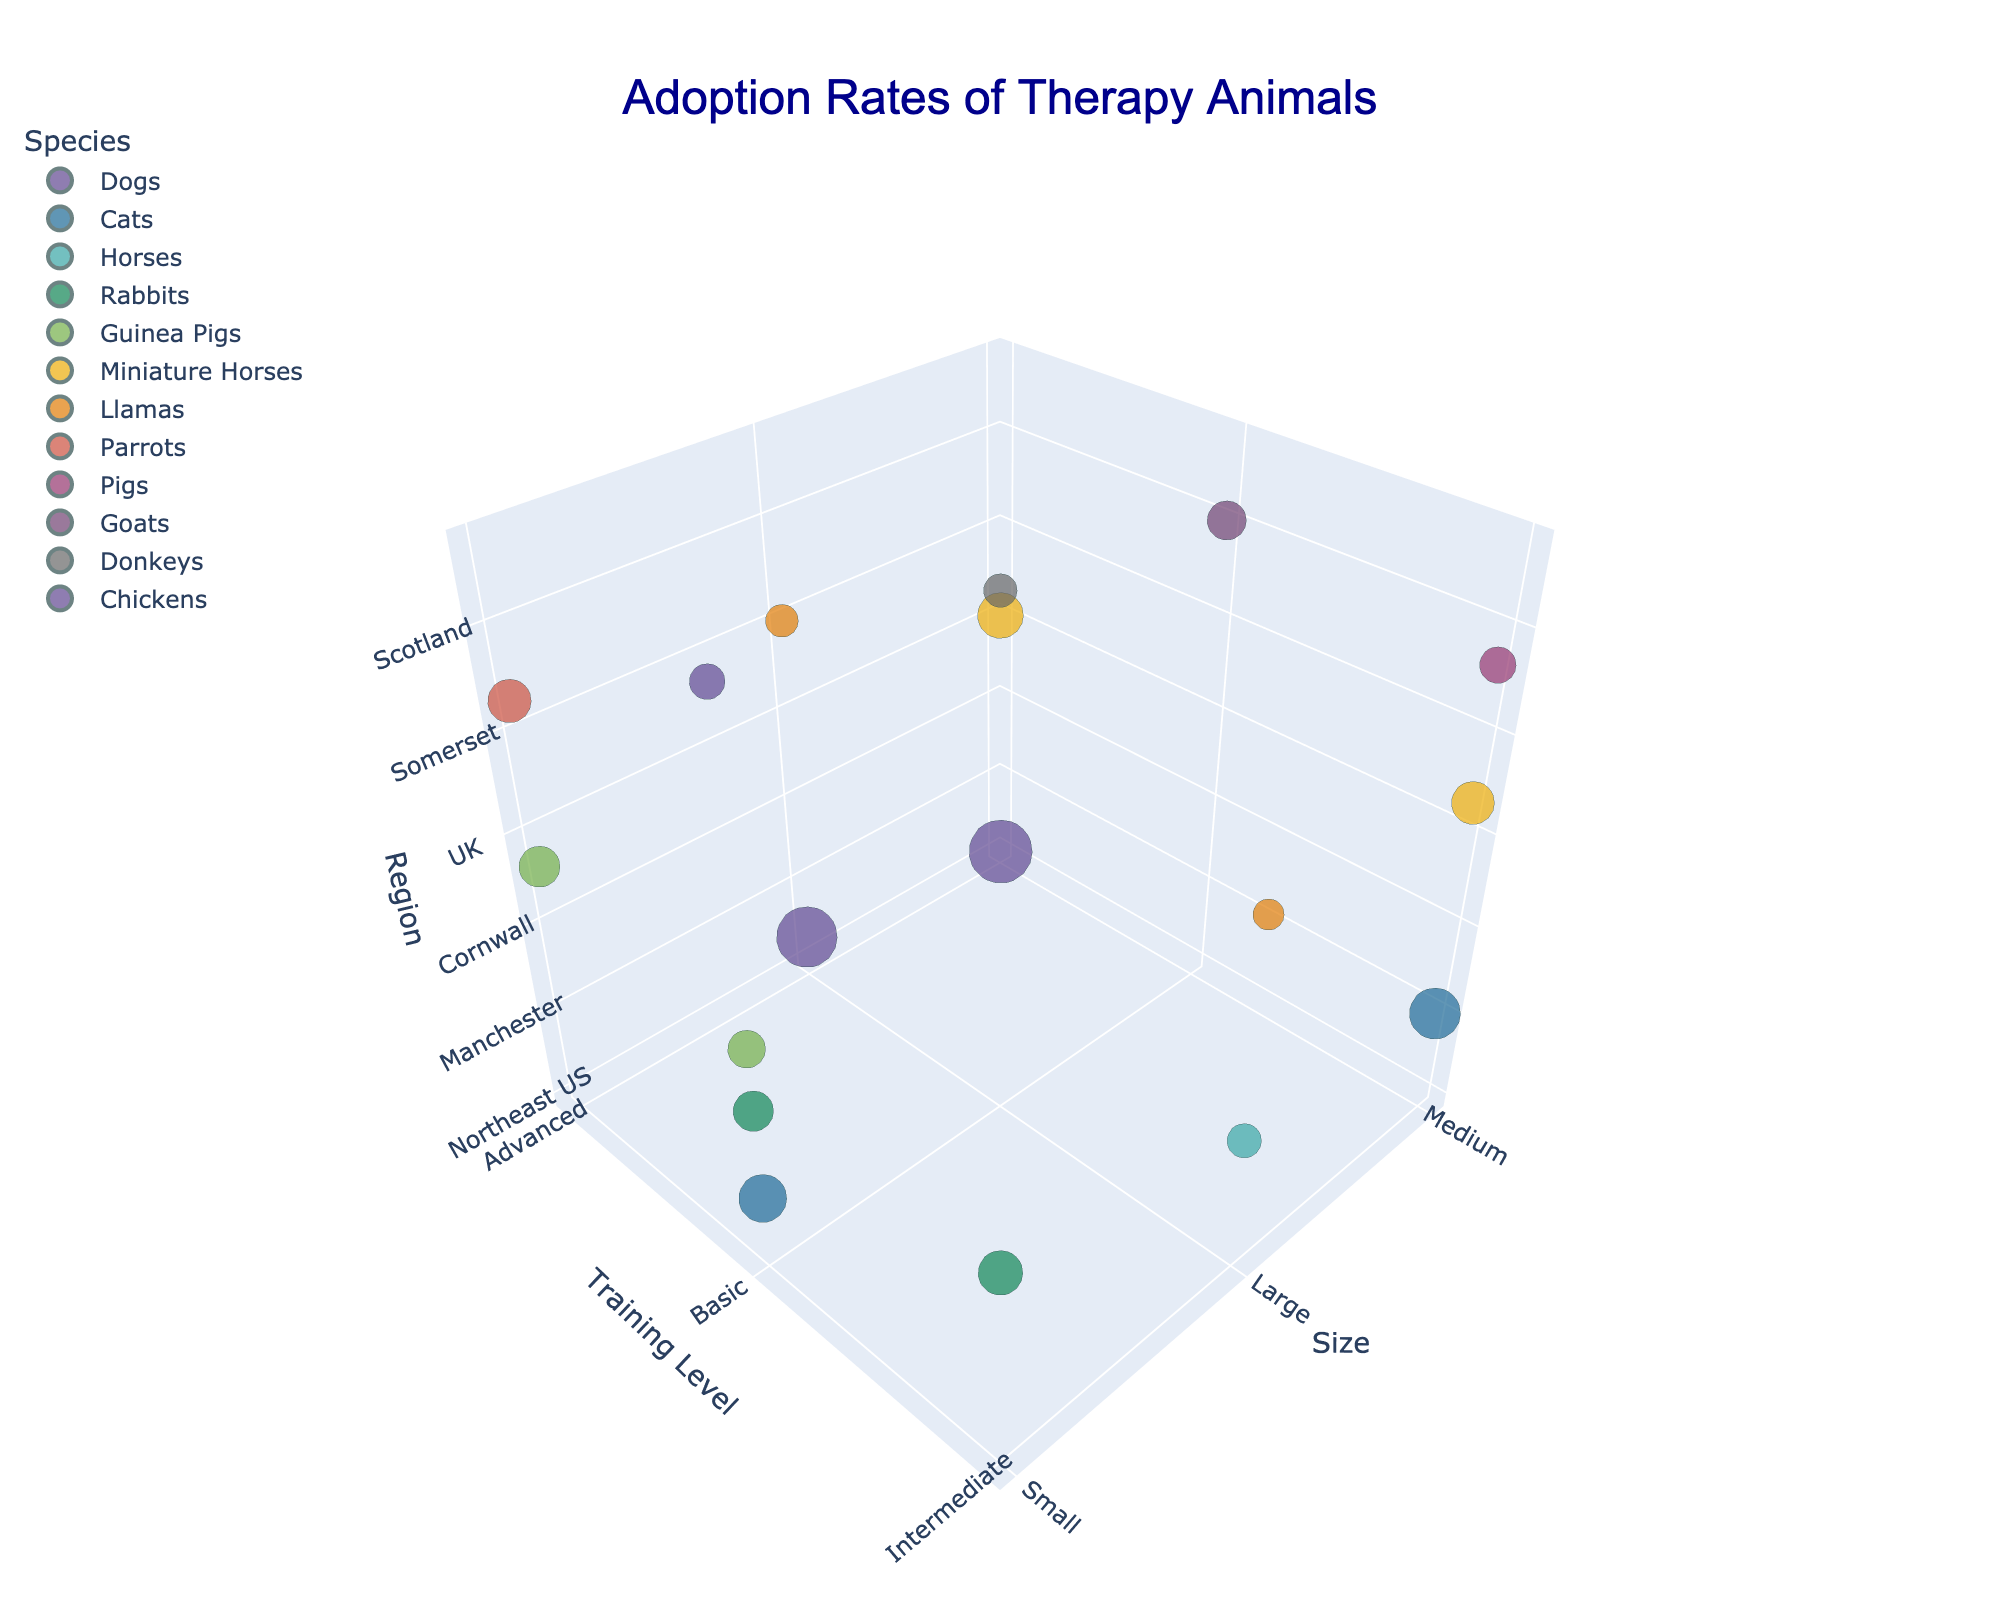How many species of therapy animals are shown in the figure? To find the number of species, count the unique labels under the 'Species' category.
Answer: 11 What is the adoption rate of medium-sized dogs with advanced training in Northeast US? Locate the bubble representing medium-sized dogs with advanced training and check the adoption rate value.
Answer: 78 Which species has the highest adoption rate, and what is it? Identify the largest bubble across all the regions, sizes, and training levels. Find out its corresponding species and adoption rate.
Answer: Dogs, 78 Compare the adoption rates of therapy animals in Australia and Ireland. Which region has a lower adoption rate, and by how much? Find the bubbles representing Australia and Ireland, then subtract the lower adoption rate from the higher one. Llamas in Australia have an adoption rate of 19, and donkeys in Ireland have 22.
Answer: Australia, by 3 What is the adoption rate for small, basic cats in Southeast US compared to medium, advanced dogs in London? Identify the respective bubbles and compare their adoption rates directly from the figure. Cats have an adoption rate of 45, and dogs have 72.
Answer: Dogs, 72; Cats, 45 Which region has more variety in the sizes of therapy animals: Southwest US or UK? Count the different sizes (small, medium, large) of therapy animals present in each region. The Southwest US has small animals (Guinea Pigs), and the UK has medium and large animals (Miniature Horses, Llamas).
Answer: UK Which animal with intermediate training has the highest adoption rate? Look for the bubble indicating the highest adoption rate among those labeled with intermediate training levels. Cats in Manchester have an adoption rate of 51.
Answer: Cats in Manchester How does the adoption rate of rabbits with basic training in West Coast US compare to those with intermediate training in Cornwall? Find the adoption rates for both groups of rabbits and compare. Rabbits in West Coast US have a rate of 32, while those in Cornwall have 39.
Answer: Intermediate-trained rabbits in Cornwall, 39 to 32 What are the regions where goats and chickens are adopted as therapy animals, and what are their adoption rates? Find the bubbles representing goats and chickens and note their regions and adoption rates. Goats are in Scotland with a rate of 30, and chickens are in Wales with a rate of 25.
Answer: Scotland, 30; Wales, 25 Which is greater, the adoption rate of advanced-trained parrots in Canada or intermediate-trained pigs in New Zealand? Compare the adoption rates of parrots and pigs from the respective regions. Advanced-trained parrots have an adoption rate of 37, and intermediate-trained pigs have 26.
Answer: Parrots, 37 